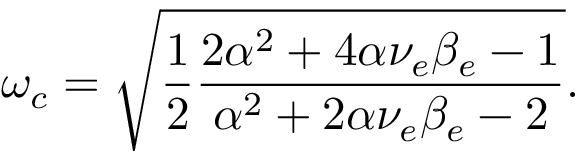Convert formula to latex. <formula><loc_0><loc_0><loc_500><loc_500>\omega _ { c } = \sqrt { \frac { 1 } { 2 } \frac { 2 \alpha ^ { 2 } + 4 \alpha \nu _ { e } \beta _ { e } - 1 } { \alpha ^ { 2 } + 2 \alpha \nu _ { e } \beta _ { e } - 2 } } .</formula> 